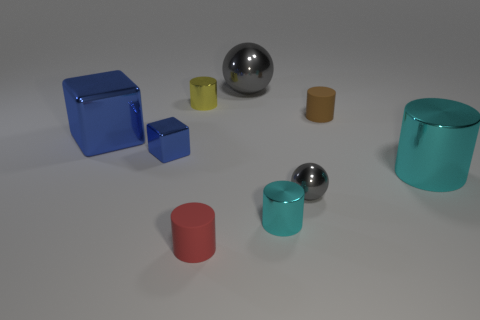Subtract 1 cylinders. How many cylinders are left? 4 Subtract all red cylinders. How many cylinders are left? 4 Subtract all gray cylinders. Subtract all yellow balls. How many cylinders are left? 5 Subtract all cylinders. How many objects are left? 4 Subtract 0 green cylinders. How many objects are left? 9 Subtract all blue cylinders. Subtract all big blue shiny blocks. How many objects are left? 8 Add 6 cubes. How many cubes are left? 8 Add 8 small gray metal spheres. How many small gray metal spheres exist? 9 